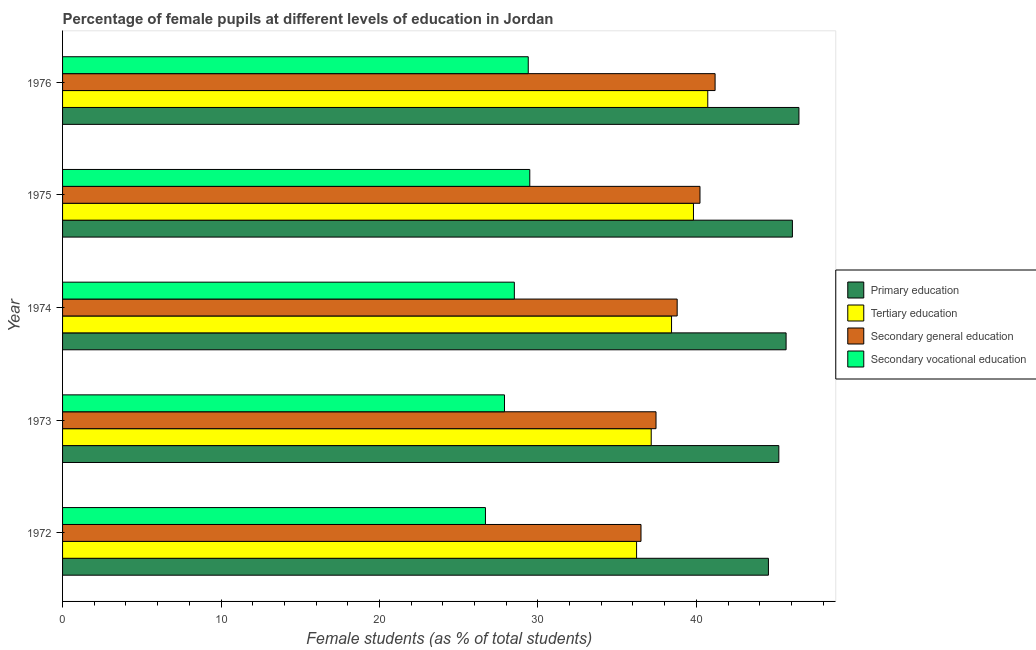Are the number of bars per tick equal to the number of legend labels?
Your response must be concise. Yes. Are the number of bars on each tick of the Y-axis equal?
Your answer should be compact. Yes. How many bars are there on the 5th tick from the top?
Offer a very short reply. 4. What is the label of the 3rd group of bars from the top?
Provide a succinct answer. 1974. In how many cases, is the number of bars for a given year not equal to the number of legend labels?
Provide a short and direct response. 0. What is the percentage of female students in secondary vocational education in 1974?
Offer a very short reply. 28.51. Across all years, what is the maximum percentage of female students in secondary education?
Provide a short and direct response. 41.18. Across all years, what is the minimum percentage of female students in tertiary education?
Provide a short and direct response. 36.23. In which year was the percentage of female students in primary education maximum?
Keep it short and to the point. 1976. What is the total percentage of female students in secondary vocational education in the graph?
Keep it short and to the point. 141.97. What is the difference between the percentage of female students in tertiary education in 1972 and that in 1976?
Your answer should be very brief. -4.49. What is the difference between the percentage of female students in primary education in 1972 and the percentage of female students in secondary education in 1975?
Your response must be concise. 4.32. What is the average percentage of female students in primary education per year?
Offer a very short reply. 45.59. In the year 1973, what is the difference between the percentage of female students in secondary vocational education and percentage of female students in secondary education?
Ensure brevity in your answer.  -9.56. In how many years, is the percentage of female students in secondary vocational education greater than 22 %?
Make the answer very short. 5. Is the percentage of female students in tertiary education in 1972 less than that in 1976?
Keep it short and to the point. Yes. What is the difference between the highest and the second highest percentage of female students in tertiary education?
Ensure brevity in your answer.  0.9. What is the difference between the highest and the lowest percentage of female students in primary education?
Your answer should be very brief. 1.93. Is the sum of the percentage of female students in primary education in 1972 and 1973 greater than the maximum percentage of female students in secondary vocational education across all years?
Provide a succinct answer. Yes. What does the 2nd bar from the top in 1974 represents?
Your answer should be compact. Secondary general education. What does the 4th bar from the bottom in 1975 represents?
Provide a short and direct response. Secondary vocational education. Is it the case that in every year, the sum of the percentage of female students in primary education and percentage of female students in tertiary education is greater than the percentage of female students in secondary education?
Offer a terse response. Yes. Are the values on the major ticks of X-axis written in scientific E-notation?
Offer a very short reply. No. What is the title of the graph?
Provide a short and direct response. Percentage of female pupils at different levels of education in Jordan. Does "Taxes on revenue" appear as one of the legend labels in the graph?
Ensure brevity in your answer.  No. What is the label or title of the X-axis?
Offer a terse response. Female students (as % of total students). What is the Female students (as % of total students) in Primary education in 1972?
Offer a terse response. 44.55. What is the Female students (as % of total students) of Tertiary education in 1972?
Ensure brevity in your answer.  36.23. What is the Female students (as % of total students) of Secondary general education in 1972?
Keep it short and to the point. 36.51. What is the Female students (as % of total students) in Secondary vocational education in 1972?
Offer a terse response. 26.69. What is the Female students (as % of total students) of Primary education in 1973?
Ensure brevity in your answer.  45.2. What is the Female students (as % of total students) of Tertiary education in 1973?
Offer a very short reply. 37.15. What is the Female students (as % of total students) of Secondary general education in 1973?
Offer a very short reply. 37.45. What is the Female students (as % of total students) in Secondary vocational education in 1973?
Your response must be concise. 27.89. What is the Female students (as % of total students) of Primary education in 1974?
Give a very brief answer. 45.66. What is the Female students (as % of total students) in Tertiary education in 1974?
Your answer should be compact. 38.43. What is the Female students (as % of total students) in Secondary general education in 1974?
Provide a short and direct response. 38.79. What is the Female students (as % of total students) of Secondary vocational education in 1974?
Provide a succinct answer. 28.51. What is the Female students (as % of total students) of Primary education in 1975?
Make the answer very short. 46.06. What is the Female students (as % of total students) in Tertiary education in 1975?
Provide a short and direct response. 39.82. What is the Female students (as % of total students) of Secondary general education in 1975?
Provide a succinct answer. 40.23. What is the Female students (as % of total students) of Secondary vocational education in 1975?
Your response must be concise. 29.49. What is the Female students (as % of total students) of Primary education in 1976?
Ensure brevity in your answer.  46.47. What is the Female students (as % of total students) in Tertiary education in 1976?
Give a very brief answer. 40.72. What is the Female students (as % of total students) in Secondary general education in 1976?
Offer a very short reply. 41.18. What is the Female students (as % of total students) in Secondary vocational education in 1976?
Your response must be concise. 29.39. Across all years, what is the maximum Female students (as % of total students) in Primary education?
Your answer should be very brief. 46.47. Across all years, what is the maximum Female students (as % of total students) in Tertiary education?
Your answer should be very brief. 40.72. Across all years, what is the maximum Female students (as % of total students) of Secondary general education?
Your answer should be compact. 41.18. Across all years, what is the maximum Female students (as % of total students) in Secondary vocational education?
Make the answer very short. 29.49. Across all years, what is the minimum Female students (as % of total students) in Primary education?
Provide a short and direct response. 44.55. Across all years, what is the minimum Female students (as % of total students) in Tertiary education?
Offer a terse response. 36.23. Across all years, what is the minimum Female students (as % of total students) of Secondary general education?
Provide a short and direct response. 36.51. Across all years, what is the minimum Female students (as % of total students) of Secondary vocational education?
Keep it short and to the point. 26.69. What is the total Female students (as % of total students) in Primary education in the graph?
Your answer should be compact. 227.95. What is the total Female students (as % of total students) in Tertiary education in the graph?
Your answer should be compact. 192.35. What is the total Female students (as % of total students) of Secondary general education in the graph?
Provide a short and direct response. 194.16. What is the total Female students (as % of total students) of Secondary vocational education in the graph?
Give a very brief answer. 141.97. What is the difference between the Female students (as % of total students) of Primary education in 1972 and that in 1973?
Keep it short and to the point. -0.66. What is the difference between the Female students (as % of total students) of Tertiary education in 1972 and that in 1973?
Keep it short and to the point. -0.92. What is the difference between the Female students (as % of total students) in Secondary general education in 1972 and that in 1973?
Provide a succinct answer. -0.95. What is the difference between the Female students (as % of total students) in Secondary vocational education in 1972 and that in 1973?
Offer a terse response. -1.2. What is the difference between the Female students (as % of total students) in Primary education in 1972 and that in 1974?
Keep it short and to the point. -1.12. What is the difference between the Female students (as % of total students) in Tertiary education in 1972 and that in 1974?
Provide a succinct answer. -2.21. What is the difference between the Female students (as % of total students) in Secondary general education in 1972 and that in 1974?
Your answer should be very brief. -2.28. What is the difference between the Female students (as % of total students) in Secondary vocational education in 1972 and that in 1974?
Your response must be concise. -1.82. What is the difference between the Female students (as % of total students) of Primary education in 1972 and that in 1975?
Your response must be concise. -1.51. What is the difference between the Female students (as % of total students) in Tertiary education in 1972 and that in 1975?
Keep it short and to the point. -3.59. What is the difference between the Female students (as % of total students) of Secondary general education in 1972 and that in 1975?
Offer a terse response. -3.72. What is the difference between the Female students (as % of total students) in Secondary vocational education in 1972 and that in 1975?
Your answer should be compact. -2.8. What is the difference between the Female students (as % of total students) of Primary education in 1972 and that in 1976?
Provide a succinct answer. -1.93. What is the difference between the Female students (as % of total students) of Tertiary education in 1972 and that in 1976?
Offer a terse response. -4.49. What is the difference between the Female students (as % of total students) in Secondary general education in 1972 and that in 1976?
Ensure brevity in your answer.  -4.68. What is the difference between the Female students (as % of total students) in Secondary vocational education in 1972 and that in 1976?
Offer a very short reply. -2.7. What is the difference between the Female students (as % of total students) in Primary education in 1973 and that in 1974?
Offer a terse response. -0.46. What is the difference between the Female students (as % of total students) in Tertiary education in 1973 and that in 1974?
Provide a short and direct response. -1.28. What is the difference between the Female students (as % of total students) in Secondary general education in 1973 and that in 1974?
Your answer should be compact. -1.34. What is the difference between the Female students (as % of total students) of Secondary vocational education in 1973 and that in 1974?
Your response must be concise. -0.62. What is the difference between the Female students (as % of total students) in Primary education in 1973 and that in 1975?
Provide a short and direct response. -0.86. What is the difference between the Female students (as % of total students) of Tertiary education in 1973 and that in 1975?
Provide a succinct answer. -2.67. What is the difference between the Female students (as % of total students) of Secondary general education in 1973 and that in 1975?
Offer a terse response. -2.77. What is the difference between the Female students (as % of total students) of Secondary vocational education in 1973 and that in 1975?
Your answer should be very brief. -1.6. What is the difference between the Female students (as % of total students) in Primary education in 1973 and that in 1976?
Offer a very short reply. -1.27. What is the difference between the Female students (as % of total students) of Tertiary education in 1973 and that in 1976?
Your response must be concise. -3.57. What is the difference between the Female students (as % of total students) in Secondary general education in 1973 and that in 1976?
Offer a terse response. -3.73. What is the difference between the Female students (as % of total students) of Secondary vocational education in 1973 and that in 1976?
Provide a short and direct response. -1.5. What is the difference between the Female students (as % of total students) in Primary education in 1974 and that in 1975?
Ensure brevity in your answer.  -0.4. What is the difference between the Female students (as % of total students) of Tertiary education in 1974 and that in 1975?
Provide a succinct answer. -1.38. What is the difference between the Female students (as % of total students) of Secondary general education in 1974 and that in 1975?
Provide a succinct answer. -1.44. What is the difference between the Female students (as % of total students) in Secondary vocational education in 1974 and that in 1975?
Your response must be concise. -0.97. What is the difference between the Female students (as % of total students) in Primary education in 1974 and that in 1976?
Your response must be concise. -0.81. What is the difference between the Female students (as % of total students) of Tertiary education in 1974 and that in 1976?
Offer a very short reply. -2.29. What is the difference between the Female students (as % of total students) of Secondary general education in 1974 and that in 1976?
Give a very brief answer. -2.39. What is the difference between the Female students (as % of total students) in Secondary vocational education in 1974 and that in 1976?
Offer a terse response. -0.88. What is the difference between the Female students (as % of total students) in Primary education in 1975 and that in 1976?
Give a very brief answer. -0.41. What is the difference between the Female students (as % of total students) in Tertiary education in 1975 and that in 1976?
Offer a terse response. -0.9. What is the difference between the Female students (as % of total students) of Secondary general education in 1975 and that in 1976?
Offer a very short reply. -0.95. What is the difference between the Female students (as % of total students) in Secondary vocational education in 1975 and that in 1976?
Provide a short and direct response. 0.1. What is the difference between the Female students (as % of total students) of Primary education in 1972 and the Female students (as % of total students) of Tertiary education in 1973?
Give a very brief answer. 7.4. What is the difference between the Female students (as % of total students) of Primary education in 1972 and the Female students (as % of total students) of Secondary general education in 1973?
Offer a very short reply. 7.09. What is the difference between the Female students (as % of total students) of Primary education in 1972 and the Female students (as % of total students) of Secondary vocational education in 1973?
Your answer should be compact. 16.66. What is the difference between the Female students (as % of total students) of Tertiary education in 1972 and the Female students (as % of total students) of Secondary general education in 1973?
Give a very brief answer. -1.23. What is the difference between the Female students (as % of total students) in Tertiary education in 1972 and the Female students (as % of total students) in Secondary vocational education in 1973?
Offer a terse response. 8.34. What is the difference between the Female students (as % of total students) in Secondary general education in 1972 and the Female students (as % of total students) in Secondary vocational education in 1973?
Give a very brief answer. 8.62. What is the difference between the Female students (as % of total students) in Primary education in 1972 and the Female students (as % of total students) in Tertiary education in 1974?
Ensure brevity in your answer.  6.11. What is the difference between the Female students (as % of total students) in Primary education in 1972 and the Female students (as % of total students) in Secondary general education in 1974?
Provide a succinct answer. 5.76. What is the difference between the Female students (as % of total students) of Primary education in 1972 and the Female students (as % of total students) of Secondary vocational education in 1974?
Your answer should be compact. 16.04. What is the difference between the Female students (as % of total students) of Tertiary education in 1972 and the Female students (as % of total students) of Secondary general education in 1974?
Offer a terse response. -2.56. What is the difference between the Female students (as % of total students) of Tertiary education in 1972 and the Female students (as % of total students) of Secondary vocational education in 1974?
Offer a very short reply. 7.71. What is the difference between the Female students (as % of total students) in Secondary general education in 1972 and the Female students (as % of total students) in Secondary vocational education in 1974?
Keep it short and to the point. 7.99. What is the difference between the Female students (as % of total students) in Primary education in 1972 and the Female students (as % of total students) in Tertiary education in 1975?
Offer a terse response. 4.73. What is the difference between the Female students (as % of total students) in Primary education in 1972 and the Female students (as % of total students) in Secondary general education in 1975?
Keep it short and to the point. 4.32. What is the difference between the Female students (as % of total students) of Primary education in 1972 and the Female students (as % of total students) of Secondary vocational education in 1975?
Offer a terse response. 15.06. What is the difference between the Female students (as % of total students) in Tertiary education in 1972 and the Female students (as % of total students) in Secondary general education in 1975?
Your response must be concise. -4. What is the difference between the Female students (as % of total students) in Tertiary education in 1972 and the Female students (as % of total students) in Secondary vocational education in 1975?
Your answer should be very brief. 6.74. What is the difference between the Female students (as % of total students) of Secondary general education in 1972 and the Female students (as % of total students) of Secondary vocational education in 1975?
Offer a very short reply. 7.02. What is the difference between the Female students (as % of total students) of Primary education in 1972 and the Female students (as % of total students) of Tertiary education in 1976?
Make the answer very short. 3.83. What is the difference between the Female students (as % of total students) of Primary education in 1972 and the Female students (as % of total students) of Secondary general education in 1976?
Your response must be concise. 3.37. What is the difference between the Female students (as % of total students) in Primary education in 1972 and the Female students (as % of total students) in Secondary vocational education in 1976?
Your answer should be compact. 15.16. What is the difference between the Female students (as % of total students) in Tertiary education in 1972 and the Female students (as % of total students) in Secondary general education in 1976?
Provide a succinct answer. -4.96. What is the difference between the Female students (as % of total students) in Tertiary education in 1972 and the Female students (as % of total students) in Secondary vocational education in 1976?
Ensure brevity in your answer.  6.84. What is the difference between the Female students (as % of total students) of Secondary general education in 1972 and the Female students (as % of total students) of Secondary vocational education in 1976?
Make the answer very short. 7.12. What is the difference between the Female students (as % of total students) of Primary education in 1973 and the Female students (as % of total students) of Tertiary education in 1974?
Give a very brief answer. 6.77. What is the difference between the Female students (as % of total students) in Primary education in 1973 and the Female students (as % of total students) in Secondary general education in 1974?
Ensure brevity in your answer.  6.42. What is the difference between the Female students (as % of total students) in Primary education in 1973 and the Female students (as % of total students) in Secondary vocational education in 1974?
Your response must be concise. 16.69. What is the difference between the Female students (as % of total students) in Tertiary education in 1973 and the Female students (as % of total students) in Secondary general education in 1974?
Provide a succinct answer. -1.64. What is the difference between the Female students (as % of total students) of Tertiary education in 1973 and the Female students (as % of total students) of Secondary vocational education in 1974?
Offer a very short reply. 8.64. What is the difference between the Female students (as % of total students) of Secondary general education in 1973 and the Female students (as % of total students) of Secondary vocational education in 1974?
Make the answer very short. 8.94. What is the difference between the Female students (as % of total students) in Primary education in 1973 and the Female students (as % of total students) in Tertiary education in 1975?
Offer a very short reply. 5.39. What is the difference between the Female students (as % of total students) of Primary education in 1973 and the Female students (as % of total students) of Secondary general education in 1975?
Provide a succinct answer. 4.98. What is the difference between the Female students (as % of total students) of Primary education in 1973 and the Female students (as % of total students) of Secondary vocational education in 1975?
Your answer should be very brief. 15.72. What is the difference between the Female students (as % of total students) of Tertiary education in 1973 and the Female students (as % of total students) of Secondary general education in 1975?
Your answer should be compact. -3.08. What is the difference between the Female students (as % of total students) of Tertiary education in 1973 and the Female students (as % of total students) of Secondary vocational education in 1975?
Provide a succinct answer. 7.66. What is the difference between the Female students (as % of total students) of Secondary general education in 1973 and the Female students (as % of total students) of Secondary vocational education in 1975?
Your answer should be compact. 7.97. What is the difference between the Female students (as % of total students) in Primary education in 1973 and the Female students (as % of total students) in Tertiary education in 1976?
Your answer should be compact. 4.48. What is the difference between the Female students (as % of total students) in Primary education in 1973 and the Female students (as % of total students) in Secondary general education in 1976?
Your answer should be compact. 4.02. What is the difference between the Female students (as % of total students) of Primary education in 1973 and the Female students (as % of total students) of Secondary vocational education in 1976?
Give a very brief answer. 15.81. What is the difference between the Female students (as % of total students) of Tertiary education in 1973 and the Female students (as % of total students) of Secondary general education in 1976?
Your answer should be compact. -4.03. What is the difference between the Female students (as % of total students) of Tertiary education in 1973 and the Female students (as % of total students) of Secondary vocational education in 1976?
Keep it short and to the point. 7.76. What is the difference between the Female students (as % of total students) of Secondary general education in 1973 and the Female students (as % of total students) of Secondary vocational education in 1976?
Your answer should be compact. 8.06. What is the difference between the Female students (as % of total students) of Primary education in 1974 and the Female students (as % of total students) of Tertiary education in 1975?
Make the answer very short. 5.85. What is the difference between the Female students (as % of total students) of Primary education in 1974 and the Female students (as % of total students) of Secondary general education in 1975?
Make the answer very short. 5.43. What is the difference between the Female students (as % of total students) in Primary education in 1974 and the Female students (as % of total students) in Secondary vocational education in 1975?
Offer a very short reply. 16.18. What is the difference between the Female students (as % of total students) in Tertiary education in 1974 and the Female students (as % of total students) in Secondary general education in 1975?
Your response must be concise. -1.79. What is the difference between the Female students (as % of total students) in Tertiary education in 1974 and the Female students (as % of total students) in Secondary vocational education in 1975?
Provide a succinct answer. 8.95. What is the difference between the Female students (as % of total students) of Secondary general education in 1974 and the Female students (as % of total students) of Secondary vocational education in 1975?
Provide a succinct answer. 9.3. What is the difference between the Female students (as % of total students) of Primary education in 1974 and the Female students (as % of total students) of Tertiary education in 1976?
Your answer should be very brief. 4.94. What is the difference between the Female students (as % of total students) in Primary education in 1974 and the Female students (as % of total students) in Secondary general education in 1976?
Give a very brief answer. 4.48. What is the difference between the Female students (as % of total students) of Primary education in 1974 and the Female students (as % of total students) of Secondary vocational education in 1976?
Offer a very short reply. 16.27. What is the difference between the Female students (as % of total students) in Tertiary education in 1974 and the Female students (as % of total students) in Secondary general education in 1976?
Your answer should be very brief. -2.75. What is the difference between the Female students (as % of total students) in Tertiary education in 1974 and the Female students (as % of total students) in Secondary vocational education in 1976?
Your answer should be very brief. 9.04. What is the difference between the Female students (as % of total students) in Secondary general education in 1974 and the Female students (as % of total students) in Secondary vocational education in 1976?
Ensure brevity in your answer.  9.4. What is the difference between the Female students (as % of total students) of Primary education in 1975 and the Female students (as % of total students) of Tertiary education in 1976?
Offer a very short reply. 5.34. What is the difference between the Female students (as % of total students) in Primary education in 1975 and the Female students (as % of total students) in Secondary general education in 1976?
Provide a short and direct response. 4.88. What is the difference between the Female students (as % of total students) in Primary education in 1975 and the Female students (as % of total students) in Secondary vocational education in 1976?
Make the answer very short. 16.67. What is the difference between the Female students (as % of total students) in Tertiary education in 1975 and the Female students (as % of total students) in Secondary general education in 1976?
Your response must be concise. -1.37. What is the difference between the Female students (as % of total students) of Tertiary education in 1975 and the Female students (as % of total students) of Secondary vocational education in 1976?
Provide a succinct answer. 10.43. What is the difference between the Female students (as % of total students) of Secondary general education in 1975 and the Female students (as % of total students) of Secondary vocational education in 1976?
Offer a very short reply. 10.84. What is the average Female students (as % of total students) in Primary education per year?
Make the answer very short. 45.59. What is the average Female students (as % of total students) in Tertiary education per year?
Offer a terse response. 38.47. What is the average Female students (as % of total students) of Secondary general education per year?
Ensure brevity in your answer.  38.83. What is the average Female students (as % of total students) in Secondary vocational education per year?
Offer a very short reply. 28.39. In the year 1972, what is the difference between the Female students (as % of total students) of Primary education and Female students (as % of total students) of Tertiary education?
Your response must be concise. 8.32. In the year 1972, what is the difference between the Female students (as % of total students) in Primary education and Female students (as % of total students) in Secondary general education?
Provide a short and direct response. 8.04. In the year 1972, what is the difference between the Female students (as % of total students) of Primary education and Female students (as % of total students) of Secondary vocational education?
Your response must be concise. 17.86. In the year 1972, what is the difference between the Female students (as % of total students) in Tertiary education and Female students (as % of total students) in Secondary general education?
Keep it short and to the point. -0.28. In the year 1972, what is the difference between the Female students (as % of total students) in Tertiary education and Female students (as % of total students) in Secondary vocational education?
Keep it short and to the point. 9.54. In the year 1972, what is the difference between the Female students (as % of total students) in Secondary general education and Female students (as % of total students) in Secondary vocational education?
Offer a very short reply. 9.82. In the year 1973, what is the difference between the Female students (as % of total students) of Primary education and Female students (as % of total students) of Tertiary education?
Give a very brief answer. 8.05. In the year 1973, what is the difference between the Female students (as % of total students) of Primary education and Female students (as % of total students) of Secondary general education?
Keep it short and to the point. 7.75. In the year 1973, what is the difference between the Female students (as % of total students) of Primary education and Female students (as % of total students) of Secondary vocational education?
Offer a very short reply. 17.31. In the year 1973, what is the difference between the Female students (as % of total students) in Tertiary education and Female students (as % of total students) in Secondary general education?
Ensure brevity in your answer.  -0.3. In the year 1973, what is the difference between the Female students (as % of total students) in Tertiary education and Female students (as % of total students) in Secondary vocational education?
Provide a short and direct response. 9.26. In the year 1973, what is the difference between the Female students (as % of total students) of Secondary general education and Female students (as % of total students) of Secondary vocational education?
Your answer should be very brief. 9.56. In the year 1974, what is the difference between the Female students (as % of total students) in Primary education and Female students (as % of total students) in Tertiary education?
Your answer should be compact. 7.23. In the year 1974, what is the difference between the Female students (as % of total students) of Primary education and Female students (as % of total students) of Secondary general education?
Offer a terse response. 6.87. In the year 1974, what is the difference between the Female students (as % of total students) of Primary education and Female students (as % of total students) of Secondary vocational education?
Your response must be concise. 17.15. In the year 1974, what is the difference between the Female students (as % of total students) in Tertiary education and Female students (as % of total students) in Secondary general education?
Offer a terse response. -0.35. In the year 1974, what is the difference between the Female students (as % of total students) of Tertiary education and Female students (as % of total students) of Secondary vocational education?
Offer a terse response. 9.92. In the year 1974, what is the difference between the Female students (as % of total students) of Secondary general education and Female students (as % of total students) of Secondary vocational education?
Ensure brevity in your answer.  10.28. In the year 1975, what is the difference between the Female students (as % of total students) in Primary education and Female students (as % of total students) in Tertiary education?
Provide a short and direct response. 6.24. In the year 1975, what is the difference between the Female students (as % of total students) of Primary education and Female students (as % of total students) of Secondary general education?
Provide a short and direct response. 5.83. In the year 1975, what is the difference between the Female students (as % of total students) of Primary education and Female students (as % of total students) of Secondary vocational education?
Your answer should be compact. 16.57. In the year 1975, what is the difference between the Female students (as % of total students) of Tertiary education and Female students (as % of total students) of Secondary general education?
Your answer should be very brief. -0.41. In the year 1975, what is the difference between the Female students (as % of total students) of Tertiary education and Female students (as % of total students) of Secondary vocational education?
Provide a short and direct response. 10.33. In the year 1975, what is the difference between the Female students (as % of total students) of Secondary general education and Female students (as % of total students) of Secondary vocational education?
Make the answer very short. 10.74. In the year 1976, what is the difference between the Female students (as % of total students) of Primary education and Female students (as % of total students) of Tertiary education?
Your answer should be very brief. 5.75. In the year 1976, what is the difference between the Female students (as % of total students) in Primary education and Female students (as % of total students) in Secondary general education?
Provide a short and direct response. 5.29. In the year 1976, what is the difference between the Female students (as % of total students) in Primary education and Female students (as % of total students) in Secondary vocational education?
Provide a short and direct response. 17.08. In the year 1976, what is the difference between the Female students (as % of total students) in Tertiary education and Female students (as % of total students) in Secondary general education?
Provide a succinct answer. -0.46. In the year 1976, what is the difference between the Female students (as % of total students) of Tertiary education and Female students (as % of total students) of Secondary vocational education?
Provide a succinct answer. 11.33. In the year 1976, what is the difference between the Female students (as % of total students) of Secondary general education and Female students (as % of total students) of Secondary vocational education?
Keep it short and to the point. 11.79. What is the ratio of the Female students (as % of total students) in Primary education in 1972 to that in 1973?
Your answer should be compact. 0.99. What is the ratio of the Female students (as % of total students) of Tertiary education in 1972 to that in 1973?
Your response must be concise. 0.98. What is the ratio of the Female students (as % of total students) of Secondary general education in 1972 to that in 1973?
Your answer should be compact. 0.97. What is the ratio of the Female students (as % of total students) of Primary education in 1972 to that in 1974?
Provide a succinct answer. 0.98. What is the ratio of the Female students (as % of total students) in Tertiary education in 1972 to that in 1974?
Make the answer very short. 0.94. What is the ratio of the Female students (as % of total students) in Secondary general education in 1972 to that in 1974?
Ensure brevity in your answer.  0.94. What is the ratio of the Female students (as % of total students) in Secondary vocational education in 1972 to that in 1974?
Your answer should be compact. 0.94. What is the ratio of the Female students (as % of total students) of Primary education in 1972 to that in 1975?
Keep it short and to the point. 0.97. What is the ratio of the Female students (as % of total students) of Tertiary education in 1972 to that in 1975?
Provide a succinct answer. 0.91. What is the ratio of the Female students (as % of total students) in Secondary general education in 1972 to that in 1975?
Offer a terse response. 0.91. What is the ratio of the Female students (as % of total students) in Secondary vocational education in 1972 to that in 1975?
Keep it short and to the point. 0.91. What is the ratio of the Female students (as % of total students) of Primary education in 1972 to that in 1976?
Ensure brevity in your answer.  0.96. What is the ratio of the Female students (as % of total students) in Tertiary education in 1972 to that in 1976?
Give a very brief answer. 0.89. What is the ratio of the Female students (as % of total students) of Secondary general education in 1972 to that in 1976?
Provide a short and direct response. 0.89. What is the ratio of the Female students (as % of total students) in Secondary vocational education in 1972 to that in 1976?
Provide a succinct answer. 0.91. What is the ratio of the Female students (as % of total students) in Tertiary education in 1973 to that in 1974?
Provide a short and direct response. 0.97. What is the ratio of the Female students (as % of total students) in Secondary general education in 1973 to that in 1974?
Offer a very short reply. 0.97. What is the ratio of the Female students (as % of total students) in Secondary vocational education in 1973 to that in 1974?
Ensure brevity in your answer.  0.98. What is the ratio of the Female students (as % of total students) in Primary education in 1973 to that in 1975?
Your response must be concise. 0.98. What is the ratio of the Female students (as % of total students) in Tertiary education in 1973 to that in 1975?
Your answer should be compact. 0.93. What is the ratio of the Female students (as % of total students) in Secondary vocational education in 1973 to that in 1975?
Give a very brief answer. 0.95. What is the ratio of the Female students (as % of total students) of Primary education in 1973 to that in 1976?
Your answer should be very brief. 0.97. What is the ratio of the Female students (as % of total students) in Tertiary education in 1973 to that in 1976?
Keep it short and to the point. 0.91. What is the ratio of the Female students (as % of total students) in Secondary general education in 1973 to that in 1976?
Make the answer very short. 0.91. What is the ratio of the Female students (as % of total students) in Secondary vocational education in 1973 to that in 1976?
Your response must be concise. 0.95. What is the ratio of the Female students (as % of total students) of Tertiary education in 1974 to that in 1975?
Your answer should be very brief. 0.97. What is the ratio of the Female students (as % of total students) of Secondary general education in 1974 to that in 1975?
Your answer should be compact. 0.96. What is the ratio of the Female students (as % of total students) of Secondary vocational education in 1974 to that in 1975?
Provide a succinct answer. 0.97. What is the ratio of the Female students (as % of total students) in Primary education in 1974 to that in 1976?
Offer a terse response. 0.98. What is the ratio of the Female students (as % of total students) of Tertiary education in 1974 to that in 1976?
Offer a terse response. 0.94. What is the ratio of the Female students (as % of total students) of Secondary general education in 1974 to that in 1976?
Keep it short and to the point. 0.94. What is the ratio of the Female students (as % of total students) in Secondary vocational education in 1974 to that in 1976?
Provide a short and direct response. 0.97. What is the ratio of the Female students (as % of total students) of Primary education in 1975 to that in 1976?
Provide a short and direct response. 0.99. What is the ratio of the Female students (as % of total students) of Tertiary education in 1975 to that in 1976?
Provide a short and direct response. 0.98. What is the ratio of the Female students (as % of total students) of Secondary general education in 1975 to that in 1976?
Keep it short and to the point. 0.98. What is the difference between the highest and the second highest Female students (as % of total students) in Primary education?
Give a very brief answer. 0.41. What is the difference between the highest and the second highest Female students (as % of total students) of Tertiary education?
Your answer should be very brief. 0.9. What is the difference between the highest and the second highest Female students (as % of total students) of Secondary general education?
Offer a terse response. 0.95. What is the difference between the highest and the second highest Female students (as % of total students) in Secondary vocational education?
Offer a terse response. 0.1. What is the difference between the highest and the lowest Female students (as % of total students) in Primary education?
Provide a succinct answer. 1.93. What is the difference between the highest and the lowest Female students (as % of total students) in Tertiary education?
Give a very brief answer. 4.49. What is the difference between the highest and the lowest Female students (as % of total students) of Secondary general education?
Your answer should be compact. 4.68. What is the difference between the highest and the lowest Female students (as % of total students) of Secondary vocational education?
Your answer should be compact. 2.8. 